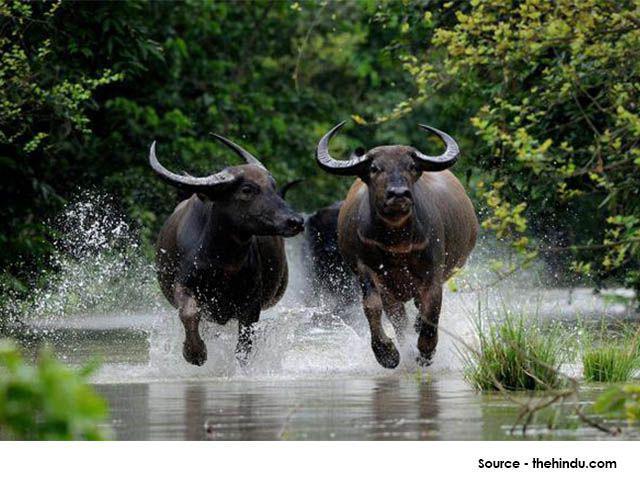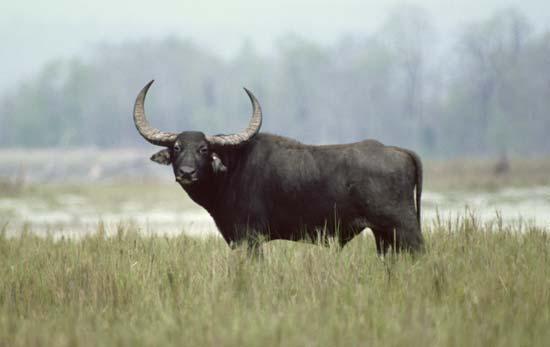The first image is the image on the left, the second image is the image on the right. Examine the images to the left and right. Is the description "the image on the right contains a water buffalo whose body is submerged in water." accurate? Answer yes or no. No. The first image is the image on the left, the second image is the image on the right. Evaluate the accuracy of this statement regarding the images: "A single horned animal is in the water.". Is it true? Answer yes or no. No. 